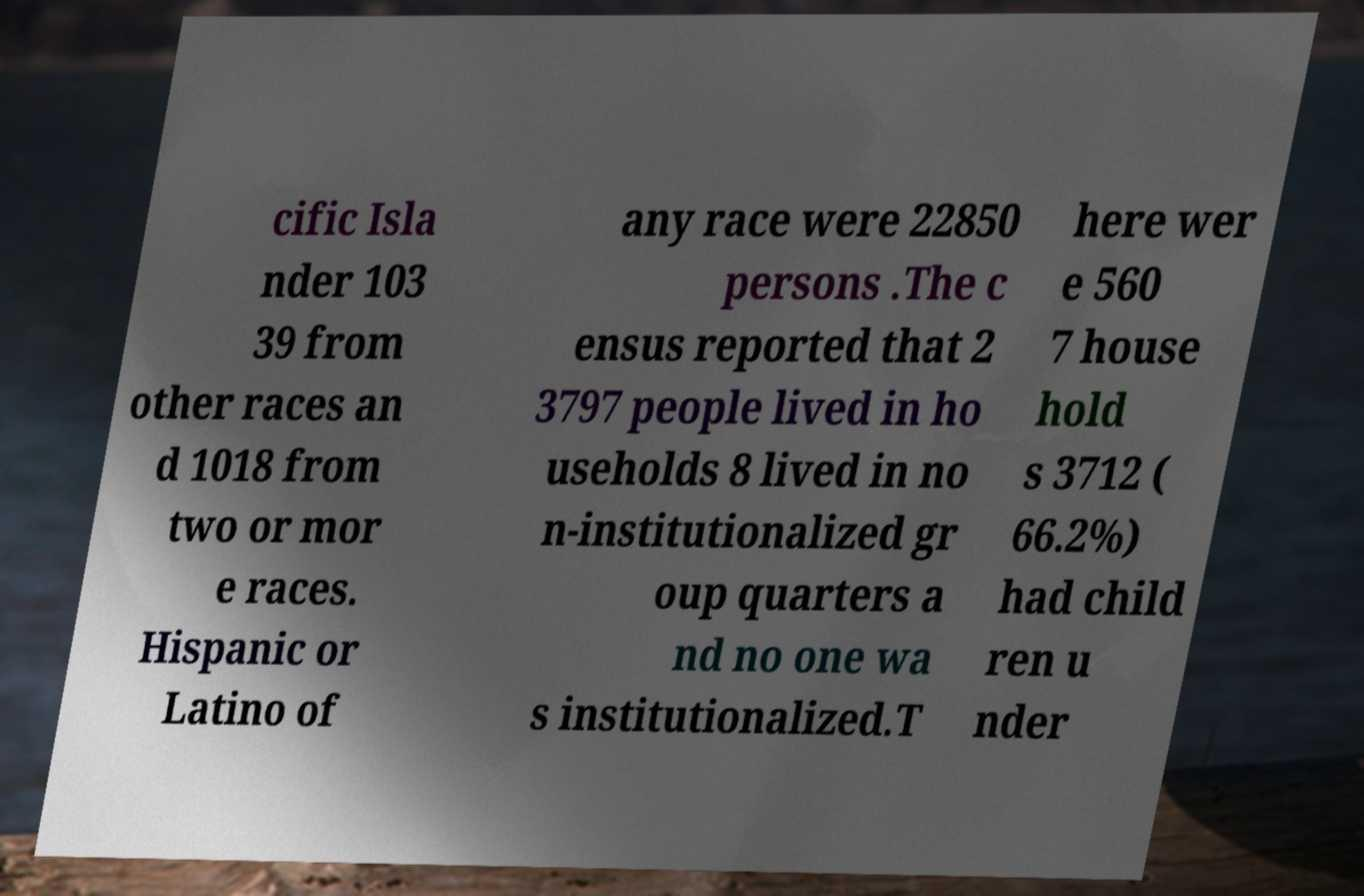What messages or text are displayed in this image? I need them in a readable, typed format. cific Isla nder 103 39 from other races an d 1018 from two or mor e races. Hispanic or Latino of any race were 22850 persons .The c ensus reported that 2 3797 people lived in ho useholds 8 lived in no n-institutionalized gr oup quarters a nd no one wa s institutionalized.T here wer e 560 7 house hold s 3712 ( 66.2%) had child ren u nder 